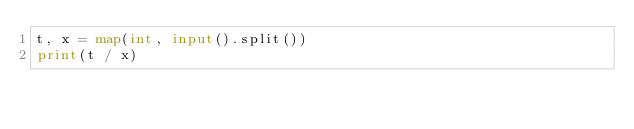Convert code to text. <code><loc_0><loc_0><loc_500><loc_500><_Python_>t, x = map(int, input().split())
print(t / x)
</code> 